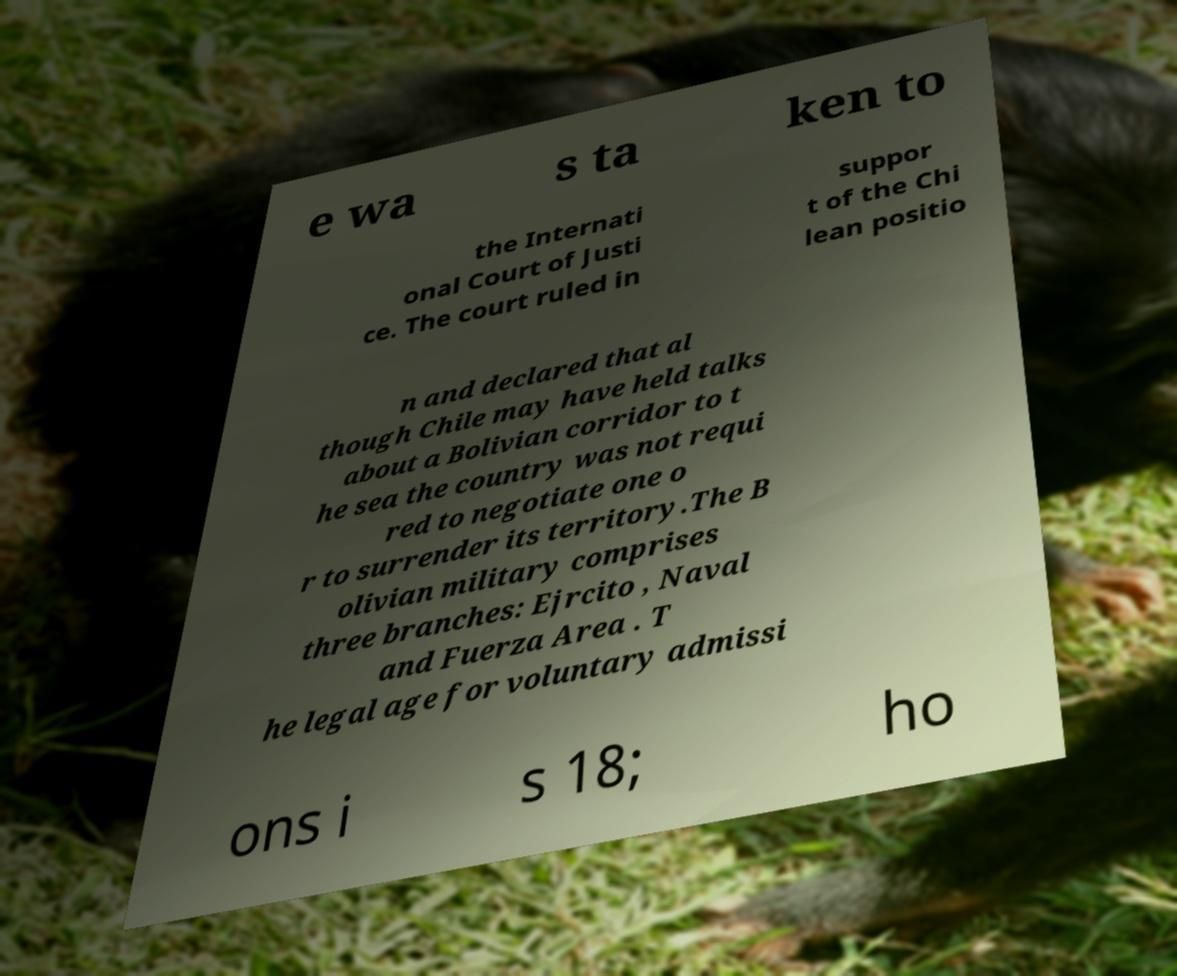Please read and relay the text visible in this image. What does it say? e wa s ta ken to the Internati onal Court of Justi ce. The court ruled in suppor t of the Chi lean positio n and declared that al though Chile may have held talks about a Bolivian corridor to t he sea the country was not requi red to negotiate one o r to surrender its territory.The B olivian military comprises three branches: Ejrcito , Naval and Fuerza Area . T he legal age for voluntary admissi ons i s 18; ho 